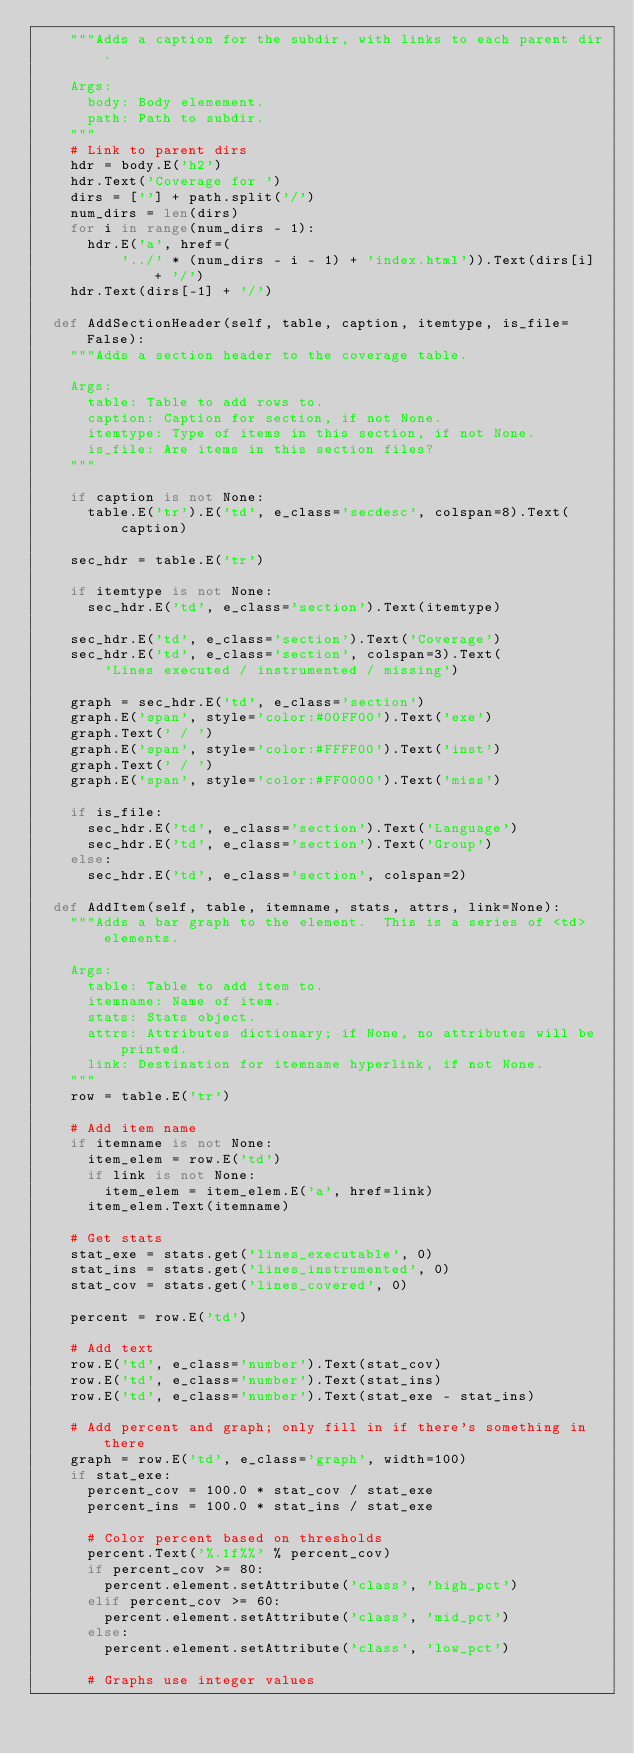<code> <loc_0><loc_0><loc_500><loc_500><_Python_>    """Adds a caption for the subdir, with links to each parent dir.

    Args:
      body: Body elemement.
      path: Path to subdir.
    """
    # Link to parent dirs
    hdr = body.E('h2')
    hdr.Text('Coverage for ')
    dirs = [''] + path.split('/')
    num_dirs = len(dirs)
    for i in range(num_dirs - 1):
      hdr.E('a', href=(
          '../' * (num_dirs - i - 1) + 'index.html')).Text(dirs[i] + '/')
    hdr.Text(dirs[-1] + '/')

  def AddSectionHeader(self, table, caption, itemtype, is_file=False):
    """Adds a section header to the coverage table.

    Args:
      table: Table to add rows to.
      caption: Caption for section, if not None.
      itemtype: Type of items in this section, if not None.
      is_file: Are items in this section files?
    """

    if caption is not None:
      table.E('tr').E('td', e_class='secdesc', colspan=8).Text(caption)

    sec_hdr = table.E('tr')

    if itemtype is not None:
      sec_hdr.E('td', e_class='section').Text(itemtype)

    sec_hdr.E('td', e_class='section').Text('Coverage')
    sec_hdr.E('td', e_class='section', colspan=3).Text(
        'Lines executed / instrumented / missing')

    graph = sec_hdr.E('td', e_class='section')
    graph.E('span', style='color:#00FF00').Text('exe')
    graph.Text(' / ')
    graph.E('span', style='color:#FFFF00').Text('inst')
    graph.Text(' / ')
    graph.E('span', style='color:#FF0000').Text('miss')

    if is_file:
      sec_hdr.E('td', e_class='section').Text('Language')
      sec_hdr.E('td', e_class='section').Text('Group')
    else:
      sec_hdr.E('td', e_class='section', colspan=2)

  def AddItem(self, table, itemname, stats, attrs, link=None):
    """Adds a bar graph to the element.  This is a series of <td> elements.

    Args:
      table: Table to add item to.
      itemname: Name of item.
      stats: Stats object.
      attrs: Attributes dictionary; if None, no attributes will be printed.
      link: Destination for itemname hyperlink, if not None.
    """
    row = table.E('tr')

    # Add item name
    if itemname is not None:
      item_elem = row.E('td')
      if link is not None:
        item_elem = item_elem.E('a', href=link)
      item_elem.Text(itemname)

    # Get stats
    stat_exe = stats.get('lines_executable', 0)
    stat_ins = stats.get('lines_instrumented', 0)
    stat_cov = stats.get('lines_covered', 0)

    percent = row.E('td')

    # Add text
    row.E('td', e_class='number').Text(stat_cov)
    row.E('td', e_class='number').Text(stat_ins)
    row.E('td', e_class='number').Text(stat_exe - stat_ins)

    # Add percent and graph; only fill in if there's something in there
    graph = row.E('td', e_class='graph', width=100)
    if stat_exe:
      percent_cov = 100.0 * stat_cov / stat_exe
      percent_ins = 100.0 * stat_ins / stat_exe

      # Color percent based on thresholds
      percent.Text('%.1f%%' % percent_cov)
      if percent_cov >= 80:
        percent.element.setAttribute('class', 'high_pct')
      elif percent_cov >= 60:
        percent.element.setAttribute('class', 'mid_pct')
      else:
        percent.element.setAttribute('class', 'low_pct')

      # Graphs use integer values</code> 